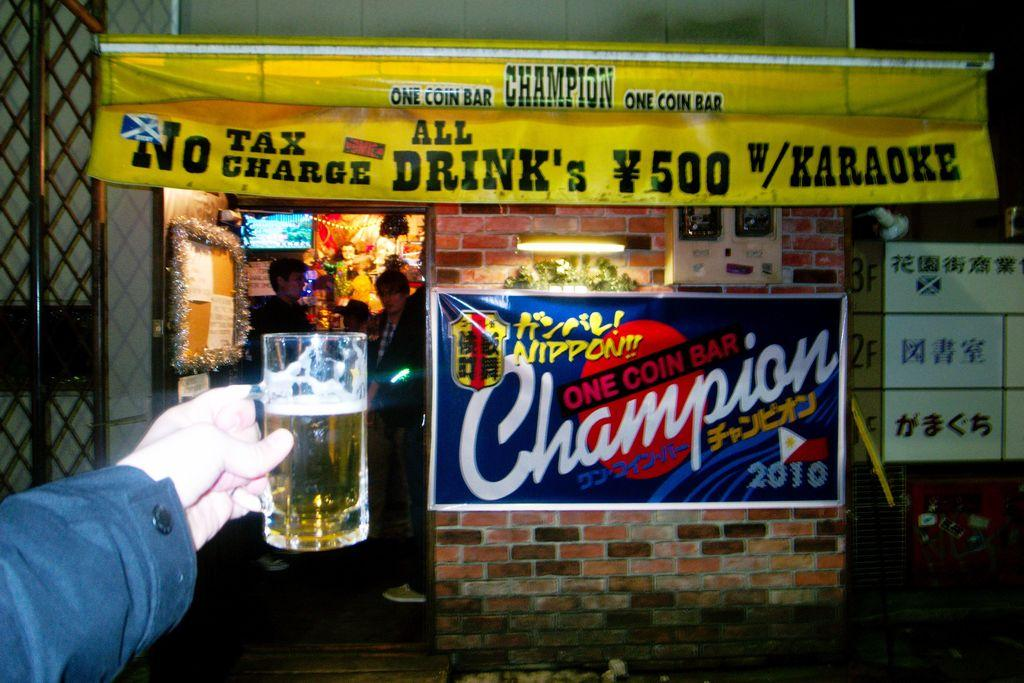<image>
Present a compact description of the photo's key features. Blue sign outside of a bar that says "One Coin Bar Champion". 